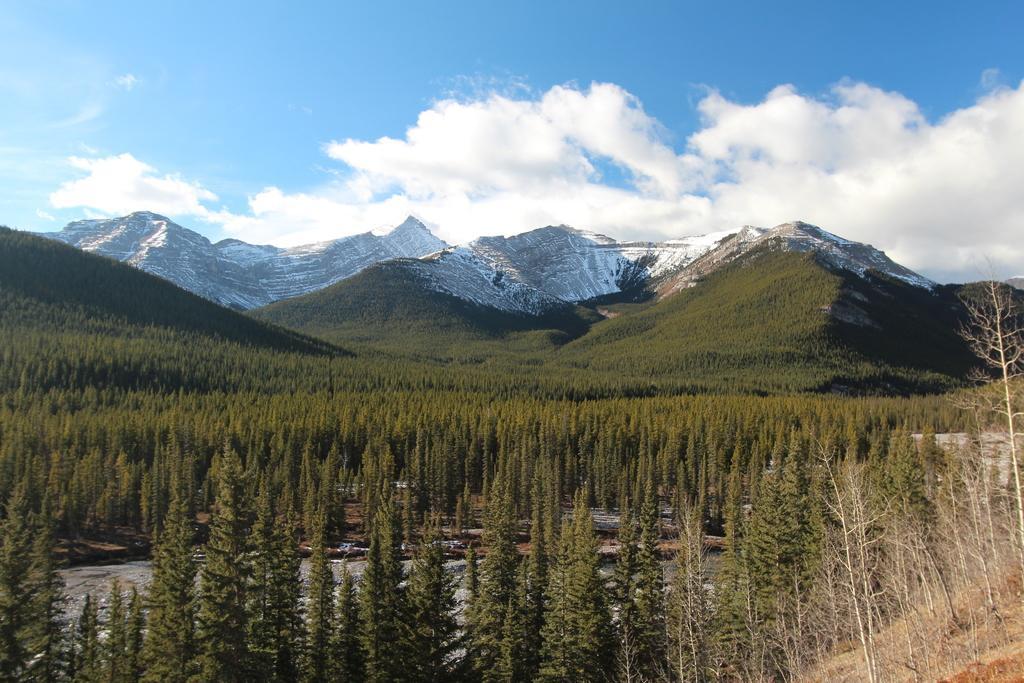Could you give a brief overview of what you see in this image? In this picture we can see trees in the front, in the background there are some hills, we can see the sky and clouds at the top of the picture. 